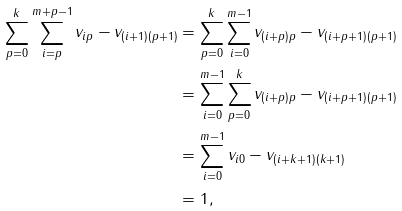<formula> <loc_0><loc_0><loc_500><loc_500>\sum _ { p = 0 } ^ { k } \sum _ { i = p } ^ { m + p - 1 } v _ { i p } - v _ { ( i + 1 ) ( p + 1 ) } & = \sum _ { p = 0 } ^ { k } \sum _ { i = 0 } ^ { m - 1 } v _ { ( i + p ) p } - v _ { ( i + p + 1 ) ( p + 1 ) } \\ & = \sum _ { i = 0 } ^ { m - 1 } \sum _ { p = 0 } ^ { k } v _ { ( i + p ) p } - v _ { ( i + p + 1 ) ( p + 1 ) } \\ & = \sum _ { i = 0 } ^ { m - 1 } v _ { i 0 } - v _ { ( i + k + 1 ) ( k + 1 ) } \\ & = 1 ,</formula> 